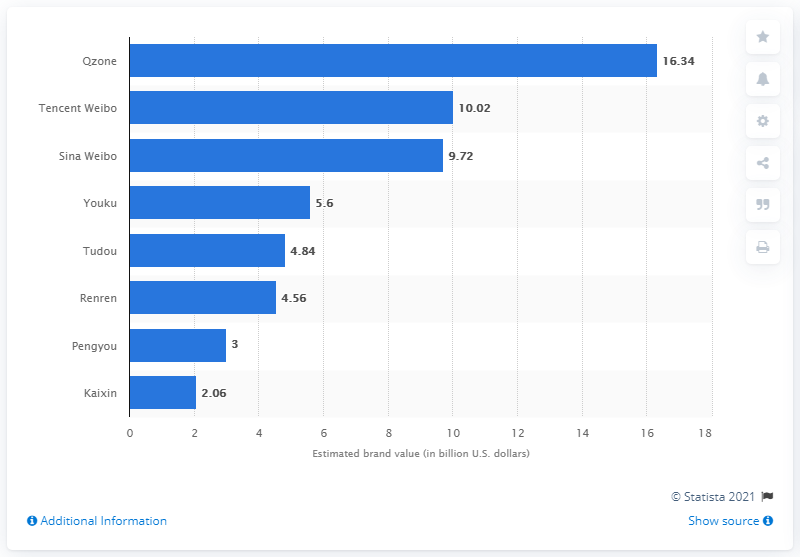Indicate a few pertinent items in this graphic. Sina Weibo was valued at approximately 9.72 US dollars. 